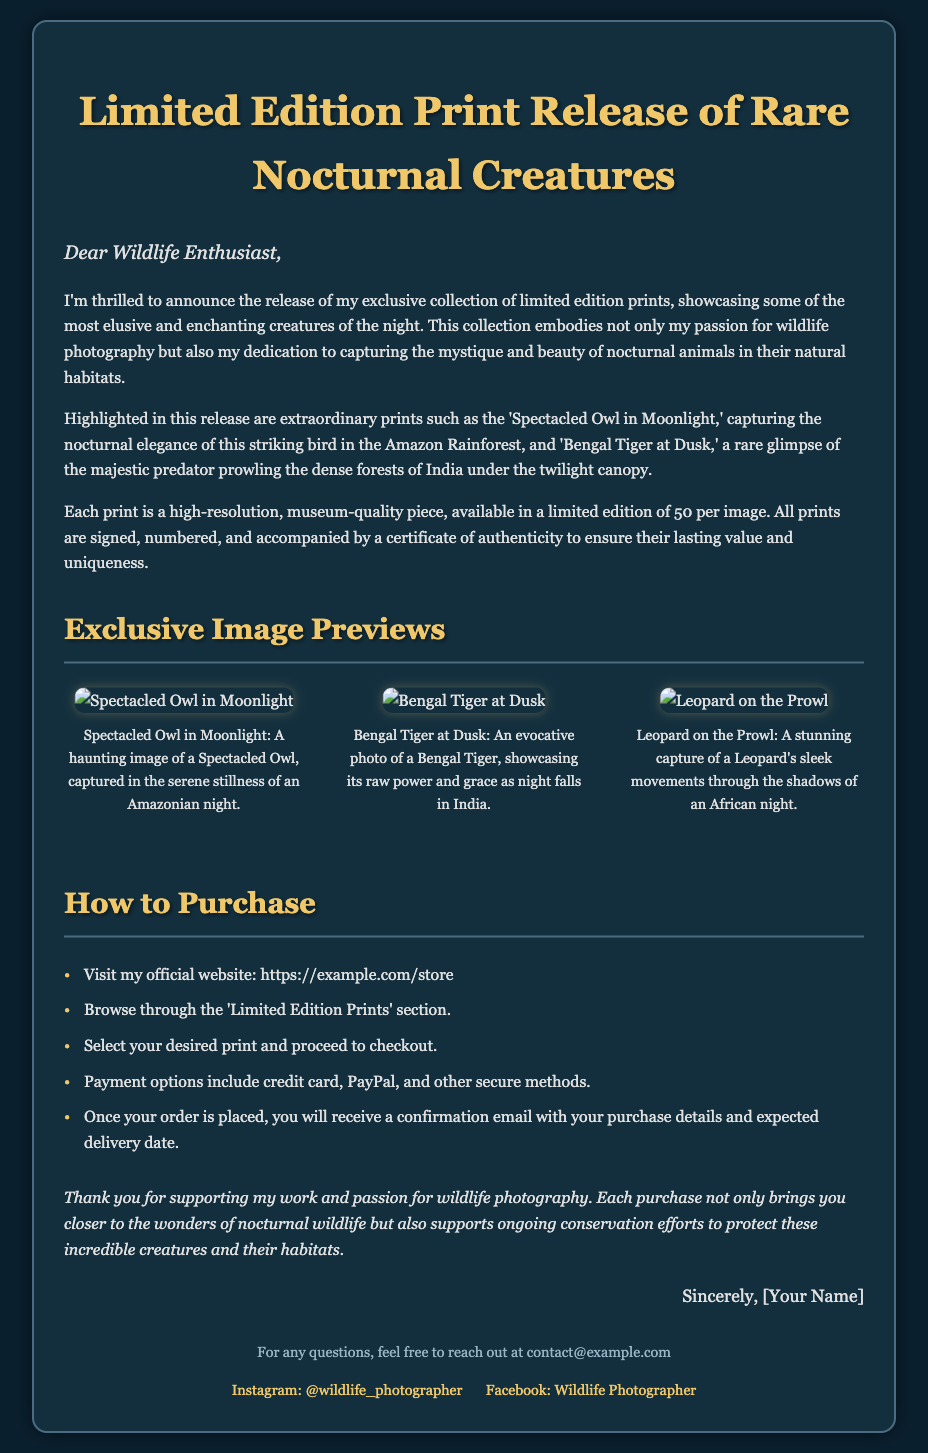What is the title of the document? The title of the document is presented at the top and conveys the main theme of the announcement.
Answer: Limited Edition Print Release of Rare Nocturnal Creatures How many prints are available for each image? The document specifies that there is a limited edition of 50 prints available for each image.
Answer: 50 What are the names of the prints featured in the collection? The document lists the specific prints, indicating the key subjects that are part of the collection.
Answer: Spectacled Owl in Moonlight, Bengal Tiger at Dusk, Leopard on the Prowl What is the URL to purchase the prints? The document provides a direct link where potential buyers can visit to make a purchase.
Answer: https://example.com/store What type of email will you receive after placing an order? The document mentions the confirmation details that buyers will receive post-purchase.
Answer: Confirmation email How does the photographer express gratitude? The document includes a section where the photographer thanks the buyers for their support and mentions the impact of their purchases.
Answer: Supports ongoing conservation efforts What can you find in the 'Limited Edition Prints' section? This section is referenced in the purchasing instructions, indicating the type of products offered.
Answer: Limited edition prints What social media platform is mentioned in the document? The document includes links to social media presence related to wildlife photography, showcasing engagement avenues for the audience.
Answer: Instagram, Facebook 